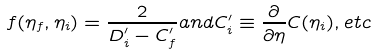Convert formula to latex. <formula><loc_0><loc_0><loc_500><loc_500>f ( \eta _ { f } , \eta _ { i } ) = \frac { 2 } { D _ { i } ^ { \prime } - C _ { f } ^ { \prime } } a n d C _ { i } ^ { \prime } \equiv \frac { \partial } { \partial \eta } C ( \eta _ { i } ) , e t c</formula> 